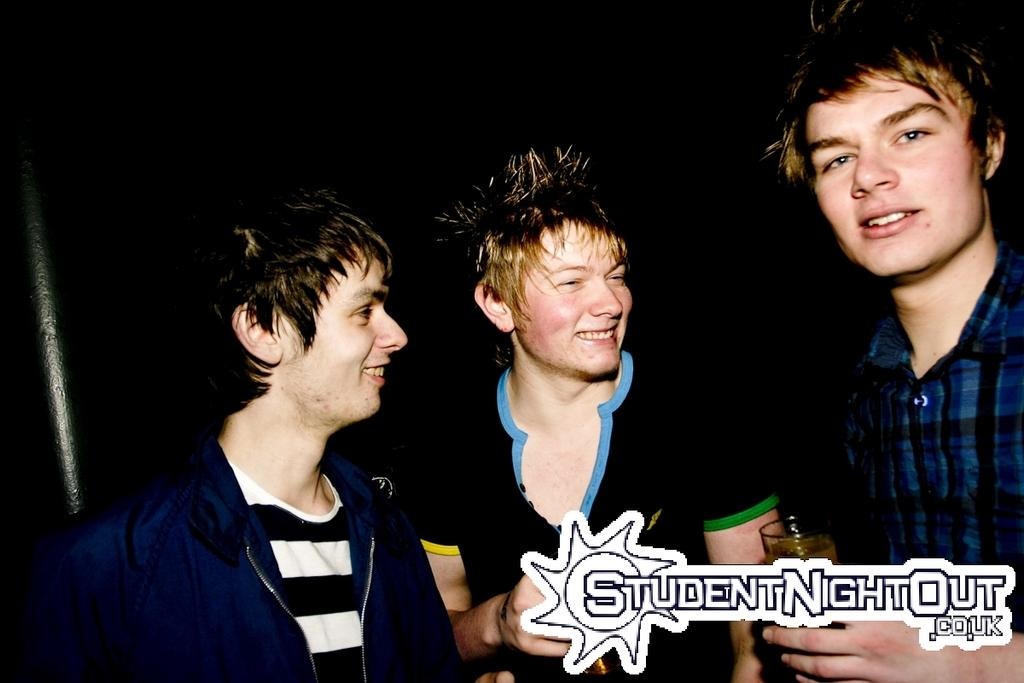How many people are in the image? There are three persons in the image. What are two of the persons holding? Two of the persons are holding a glass of drink. Is there any text or image in a specific corner of the image? Yes, there is text or an image in the right bottom corner of the image. What type of sweater is the person in the image wearing? There is no information about a sweater or any clothing in the image, so it cannot be determined. 